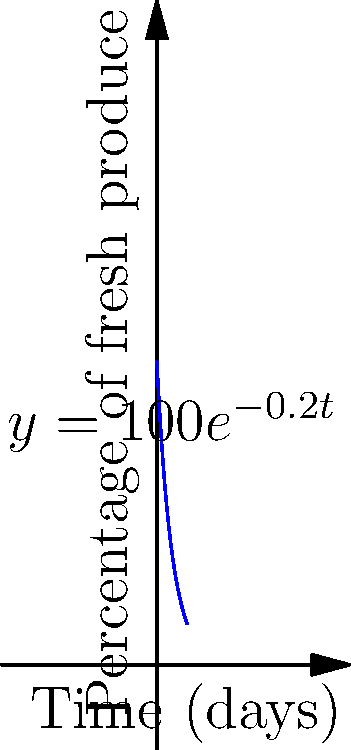As a food industry analyst, you're studying the decay rate of fresh produce in a new storage facility developed by Van Eerd's company. The graph shows the percentage of fresh produce over time, following the equation $y = 100e^{-0.2t}$, where $y$ is the percentage of fresh produce and $t$ is time in days. At what rate is the percentage of fresh produce changing after 5 days? To find the rate of change at 5 days, we need to calculate the derivative of the function and evaluate it at t = 5.

1) The original function is $y = 100e^{-0.2t}$

2) The derivative of $e^x$ is $e^x$, and using the chain rule, we get:
   $\frac{dy}{dt} = 100 \cdot (-0.2) \cdot e^{-0.2t} = -20e^{-0.2t}$

3) To find the rate of change at 5 days, substitute t = 5:
   $\frac{dy}{dt}|_{t=5} = -20e^{-0.2(5)} = -20e^{-1} \approx -7.36$

4) The negative sign indicates that the percentage is decreasing.

5) Therefore, after 5 days, the percentage of fresh produce is decreasing at a rate of approximately 7.36% per day.
Answer: $-7.36\%$ per day 